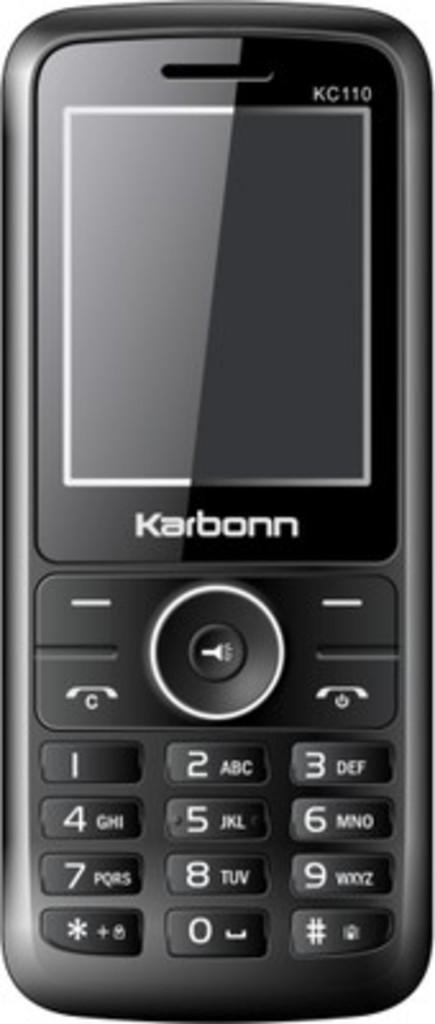Which company made this cellphone?
Provide a succinct answer. Karbonn. 